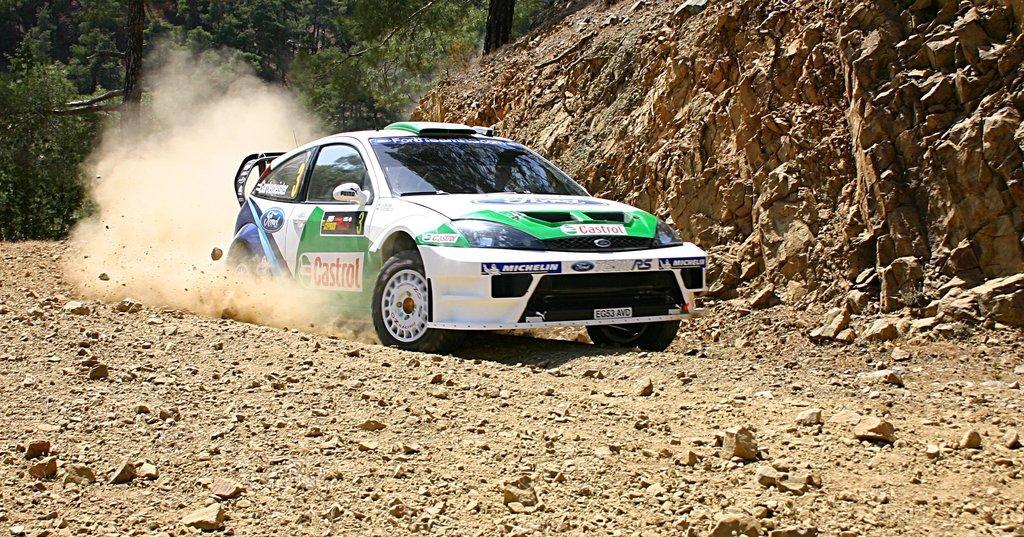In one or two sentences, can you explain what this image depicts? In this picture we can see a car, stones on the ground, rocks, dust and in the background we can see trees. 